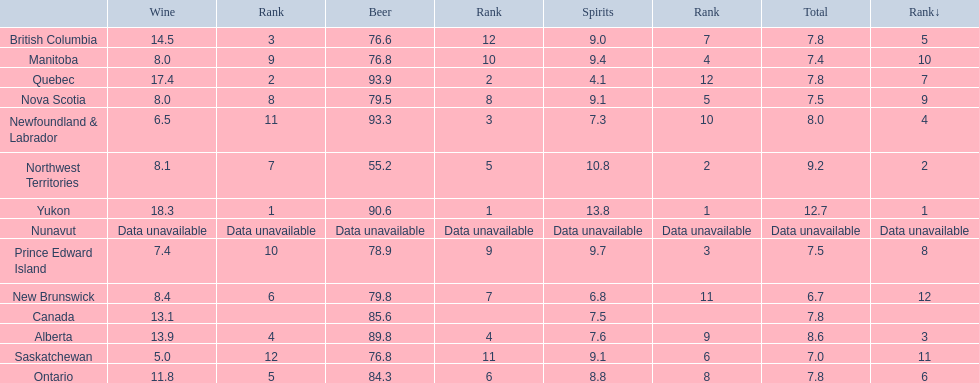What are all the canadian regions? Yukon, Northwest Territories, Alberta, Newfoundland & Labrador, British Columbia, Ontario, Quebec, Prince Edward Island, Nova Scotia, Manitoba, Saskatchewan, New Brunswick, Nunavut, Canada. What was the spirits consumption? 13.8, 10.8, 7.6, 7.3, 9.0, 8.8, 4.1, 9.7, 9.1, 9.4, 9.1, 6.8, Data unavailable, 7.5. What was quebec's spirit consumption? 4.1. 